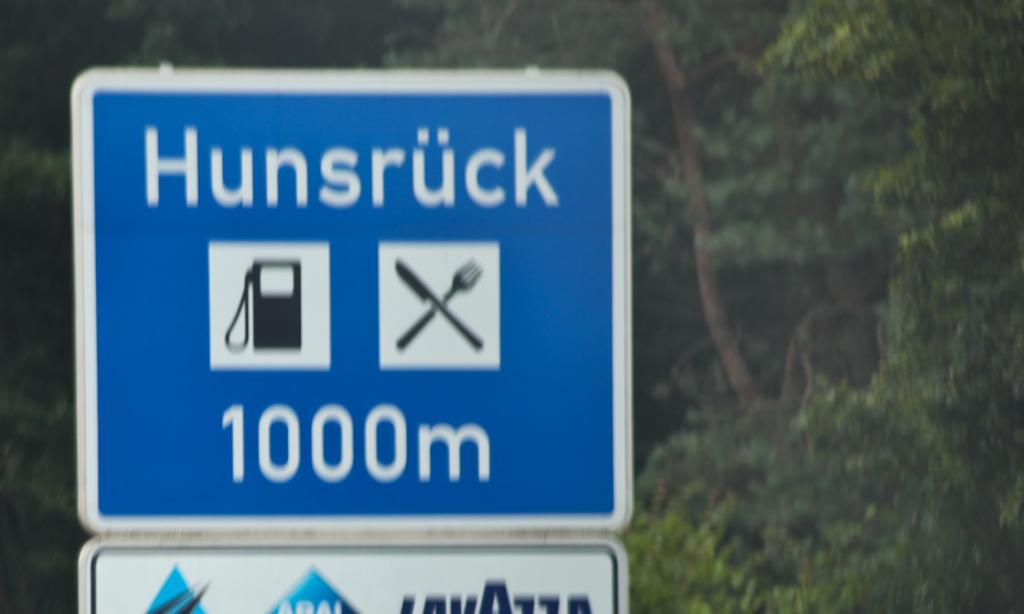Provide a one-sentence caption for the provided image. roadsign that show Hunsruck is in 1000m and has food and gas places. 